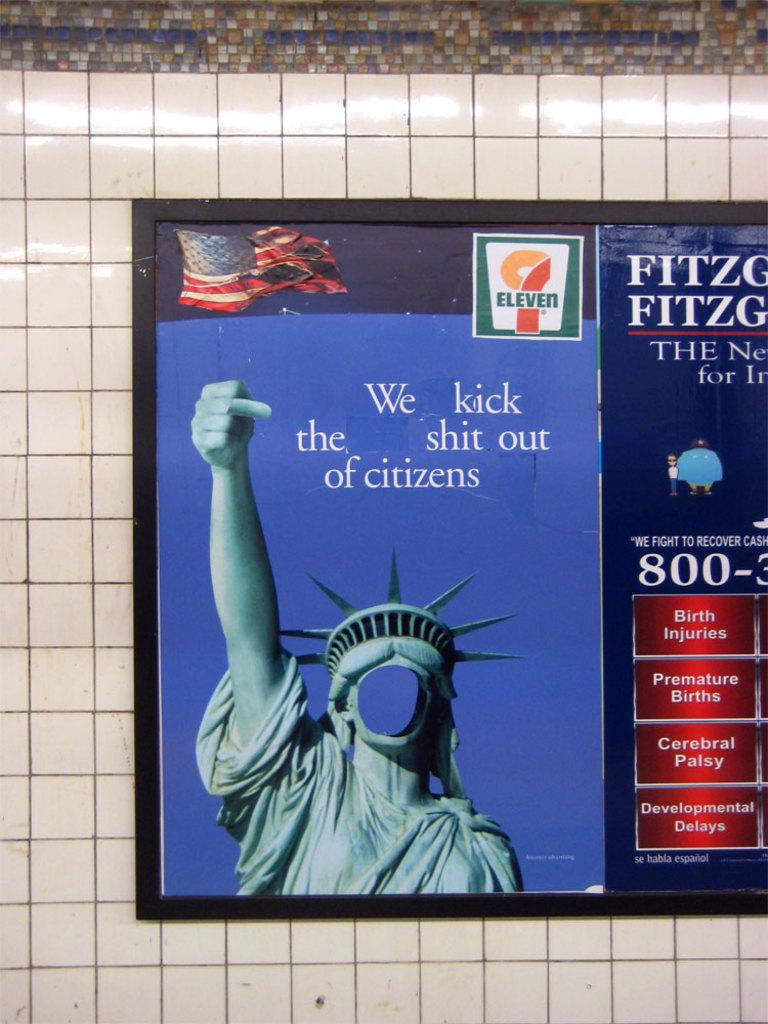<image>
Give a short and clear explanation of the subsequent image. A mocking poster of the statue of liberty with 9 eleven in the corner. 